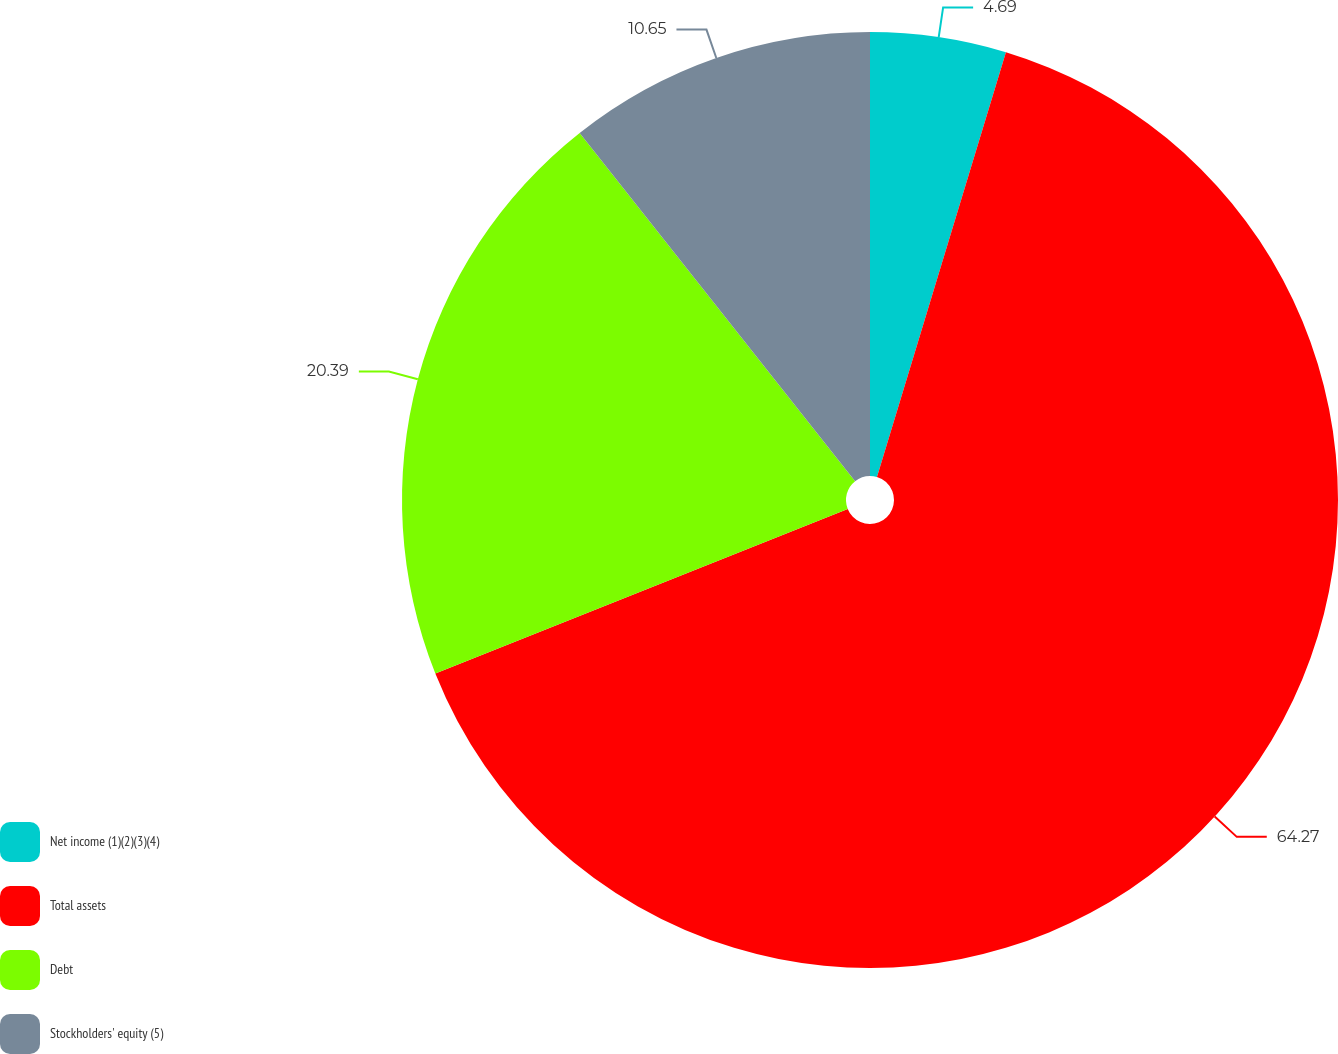Convert chart to OTSL. <chart><loc_0><loc_0><loc_500><loc_500><pie_chart><fcel>Net income (1)(2)(3)(4)<fcel>Total assets<fcel>Debt<fcel>Stockholders' equity (5)<nl><fcel>4.69%<fcel>64.26%<fcel>20.39%<fcel>10.65%<nl></chart> 